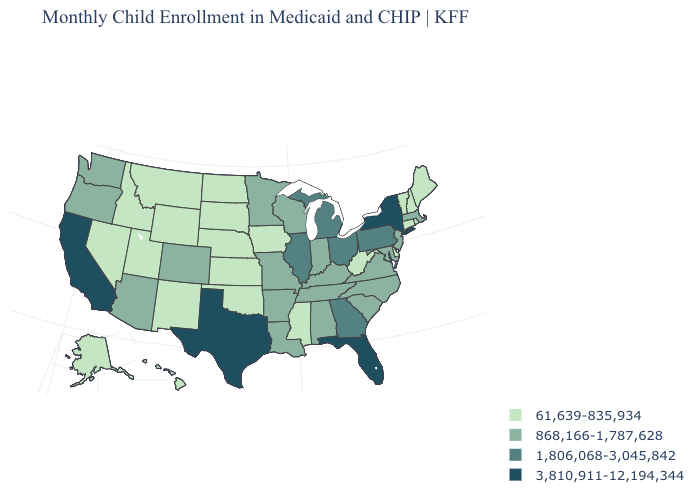Name the states that have a value in the range 61,639-835,934?
Be succinct. Alaska, Connecticut, Delaware, Hawaii, Idaho, Iowa, Kansas, Maine, Mississippi, Montana, Nebraska, Nevada, New Hampshire, New Mexico, North Dakota, Oklahoma, Rhode Island, South Dakota, Utah, Vermont, West Virginia, Wyoming. Name the states that have a value in the range 3,810,911-12,194,344?
Short answer required. California, Florida, New York, Texas. Among the states that border North Dakota , does South Dakota have the lowest value?
Quick response, please. Yes. Name the states that have a value in the range 61,639-835,934?
Give a very brief answer. Alaska, Connecticut, Delaware, Hawaii, Idaho, Iowa, Kansas, Maine, Mississippi, Montana, Nebraska, Nevada, New Hampshire, New Mexico, North Dakota, Oklahoma, Rhode Island, South Dakota, Utah, Vermont, West Virginia, Wyoming. Does the first symbol in the legend represent the smallest category?
Give a very brief answer. Yes. Name the states that have a value in the range 868,166-1,787,628?
Answer briefly. Alabama, Arizona, Arkansas, Colorado, Indiana, Kentucky, Louisiana, Maryland, Massachusetts, Minnesota, Missouri, New Jersey, North Carolina, Oregon, South Carolina, Tennessee, Virginia, Washington, Wisconsin. What is the lowest value in the West?
Give a very brief answer. 61,639-835,934. Name the states that have a value in the range 61,639-835,934?
Write a very short answer. Alaska, Connecticut, Delaware, Hawaii, Idaho, Iowa, Kansas, Maine, Mississippi, Montana, Nebraska, Nevada, New Hampshire, New Mexico, North Dakota, Oklahoma, Rhode Island, South Dakota, Utah, Vermont, West Virginia, Wyoming. Which states have the highest value in the USA?
Quick response, please. California, Florida, New York, Texas. Does Iowa have a lower value than Kentucky?
Write a very short answer. Yes. Name the states that have a value in the range 61,639-835,934?
Short answer required. Alaska, Connecticut, Delaware, Hawaii, Idaho, Iowa, Kansas, Maine, Mississippi, Montana, Nebraska, Nevada, New Hampshire, New Mexico, North Dakota, Oklahoma, Rhode Island, South Dakota, Utah, Vermont, West Virginia, Wyoming. Among the states that border Georgia , does Florida have the highest value?
Keep it brief. Yes. What is the value of South Carolina?
Keep it brief. 868,166-1,787,628. Which states hav the highest value in the West?
Be succinct. California. What is the value of Maine?
Write a very short answer. 61,639-835,934. 